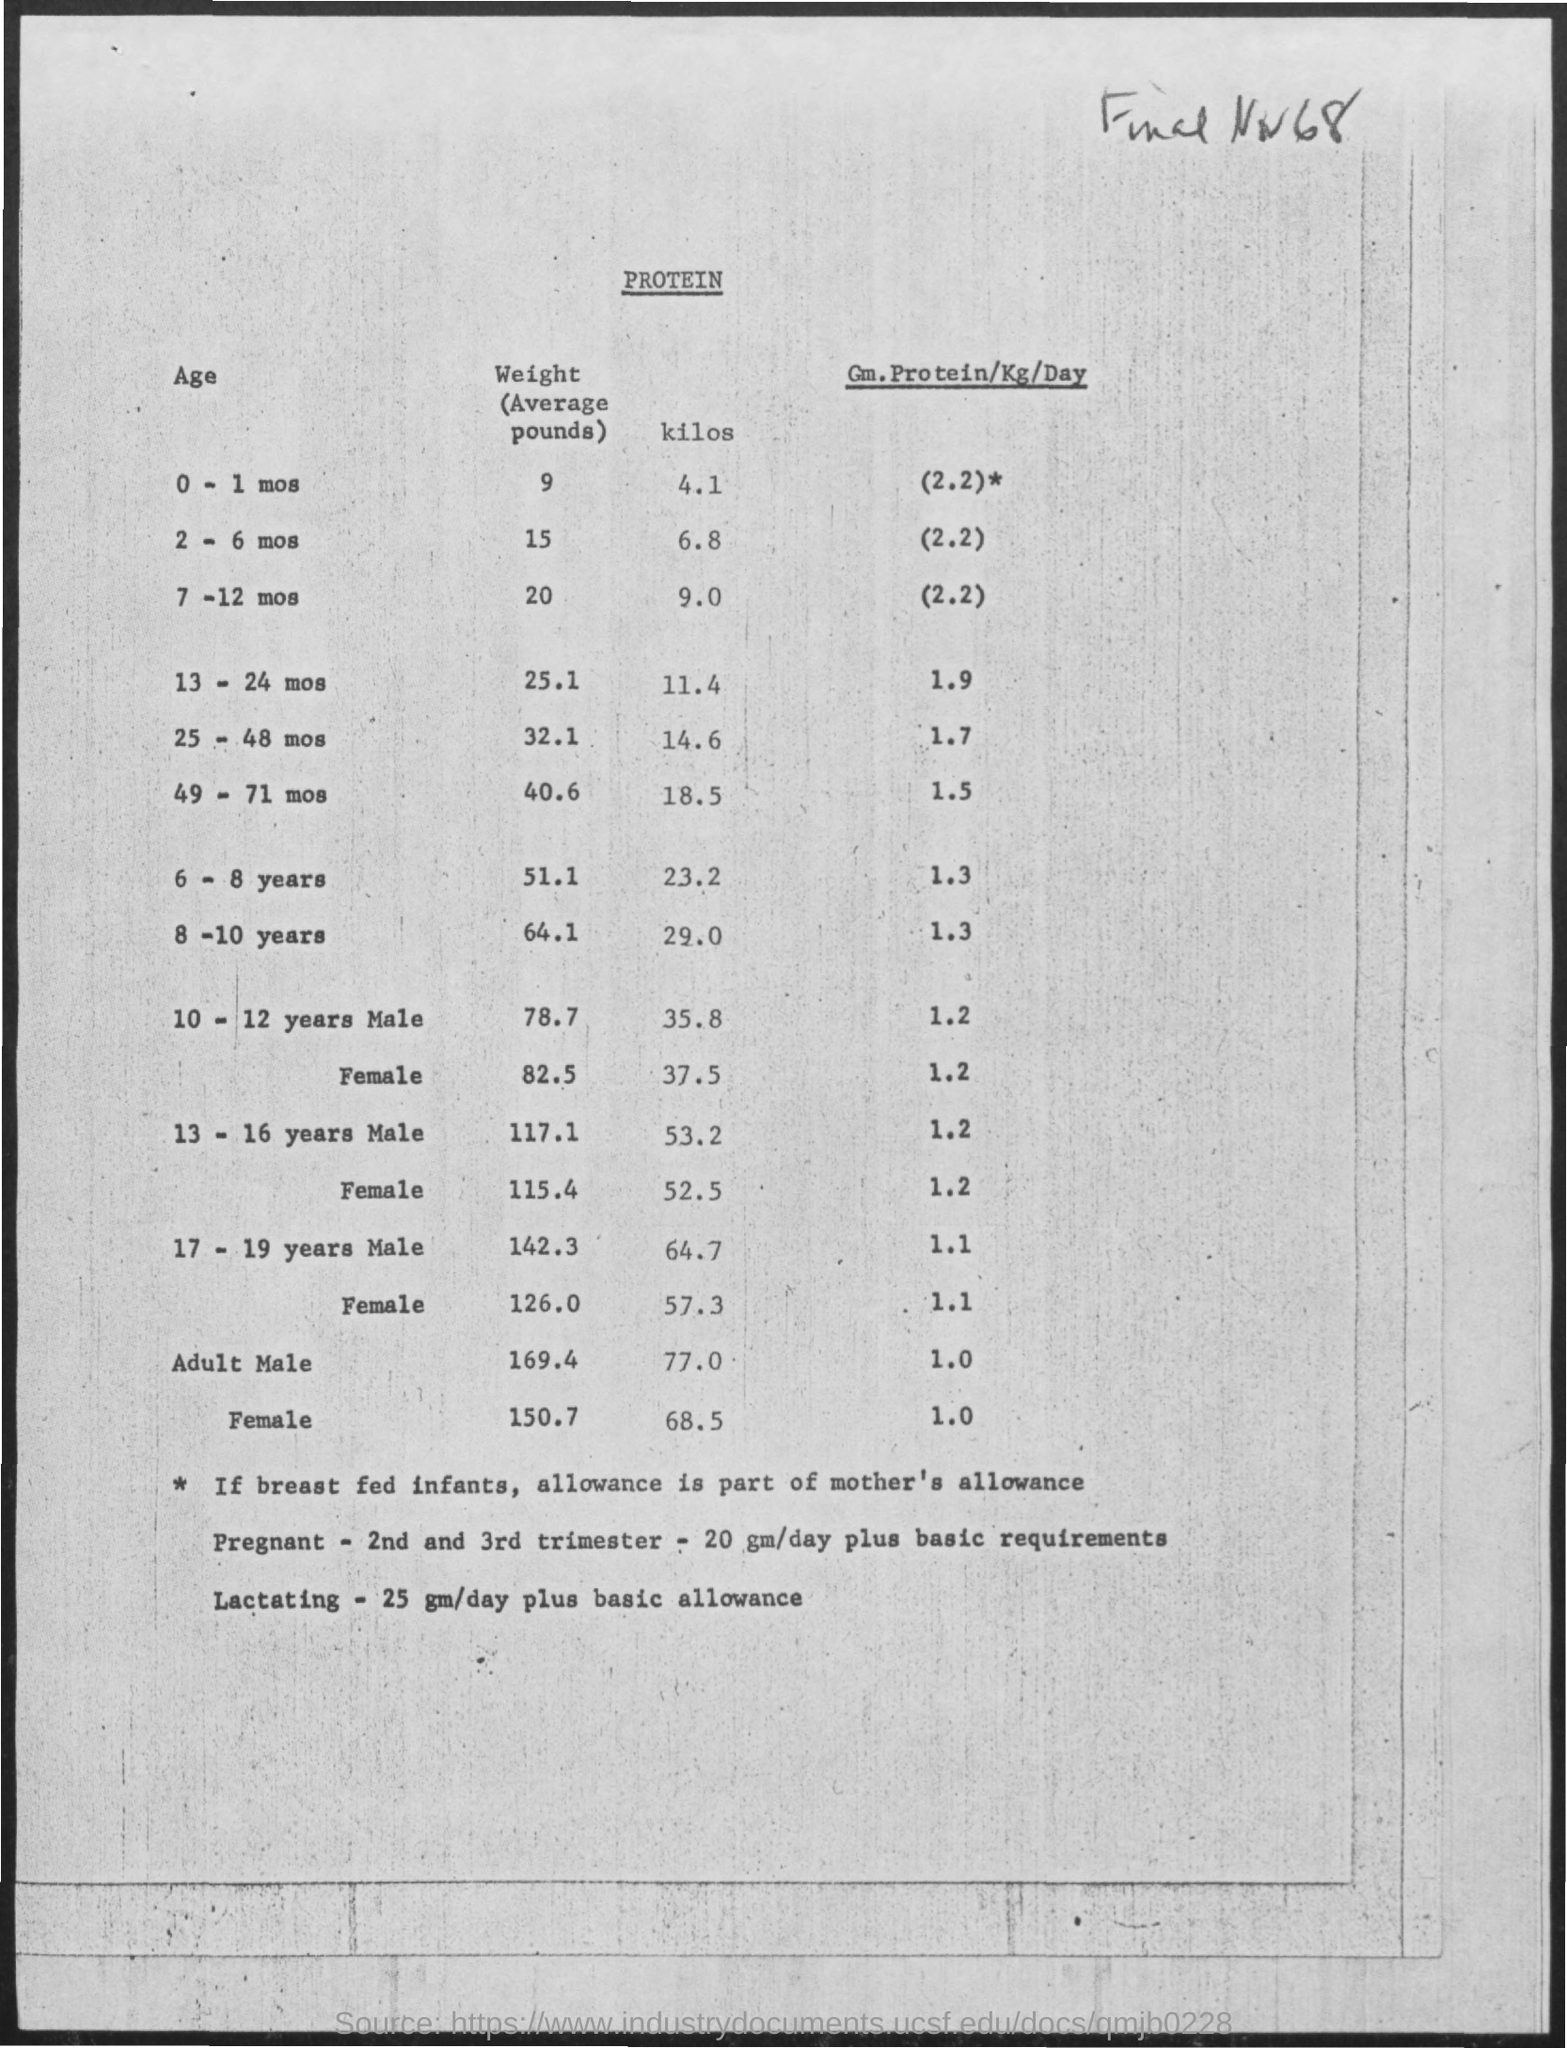Outline some significant characteristics in this image. The average weight for infants aged 7-12 months is approximately 9 kilograms. The average weight for a 2-6 month old baby is 15 pounds. The average weight for children aged 6-8 years old is approximately 51.1 pounds. The average weight for 8-10 year olds is approximately 64.1 pounds. The average weight for infants aged 0-1 months is approximately 4.1 kilos. 